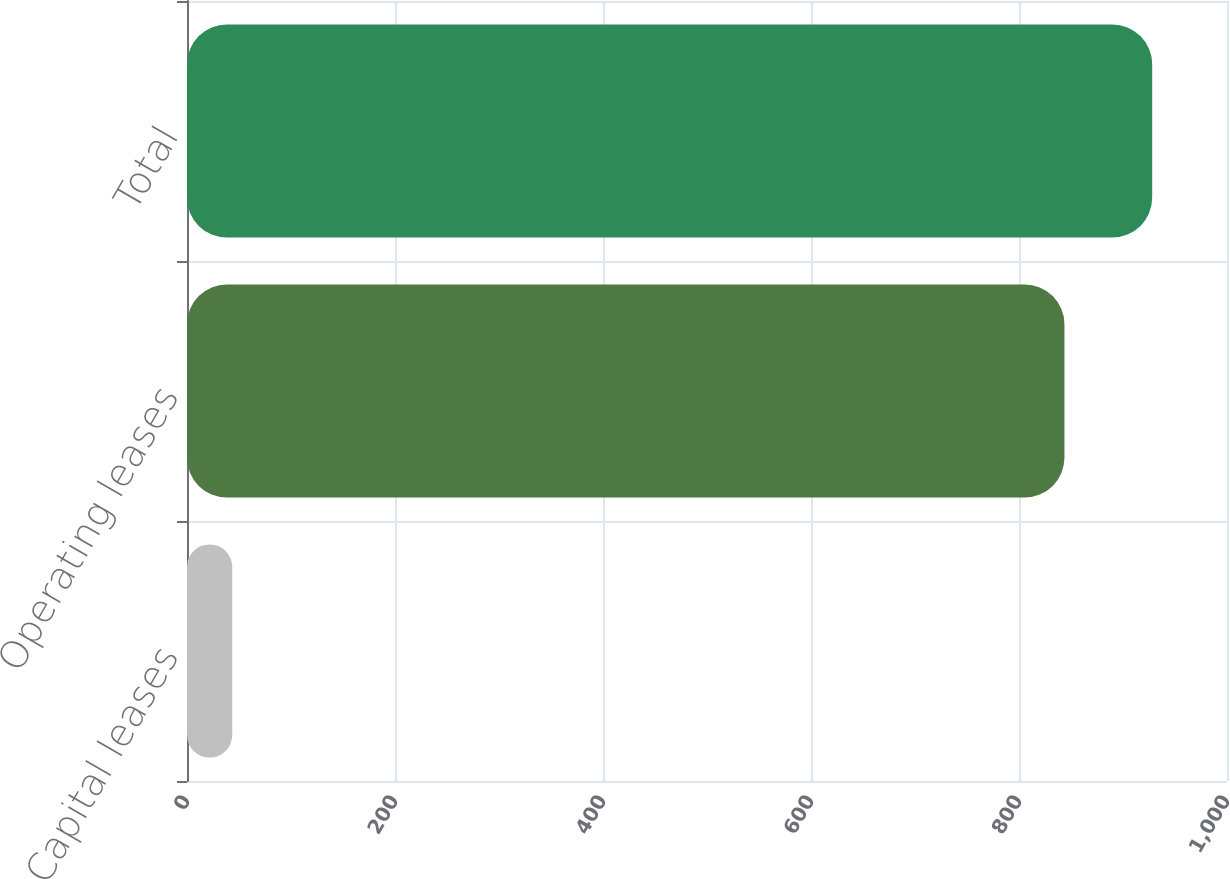Convert chart. <chart><loc_0><loc_0><loc_500><loc_500><bar_chart><fcel>Capital leases<fcel>Operating leases<fcel>Total<nl><fcel>43.5<fcel>843.7<fcel>928.07<nl></chart> 